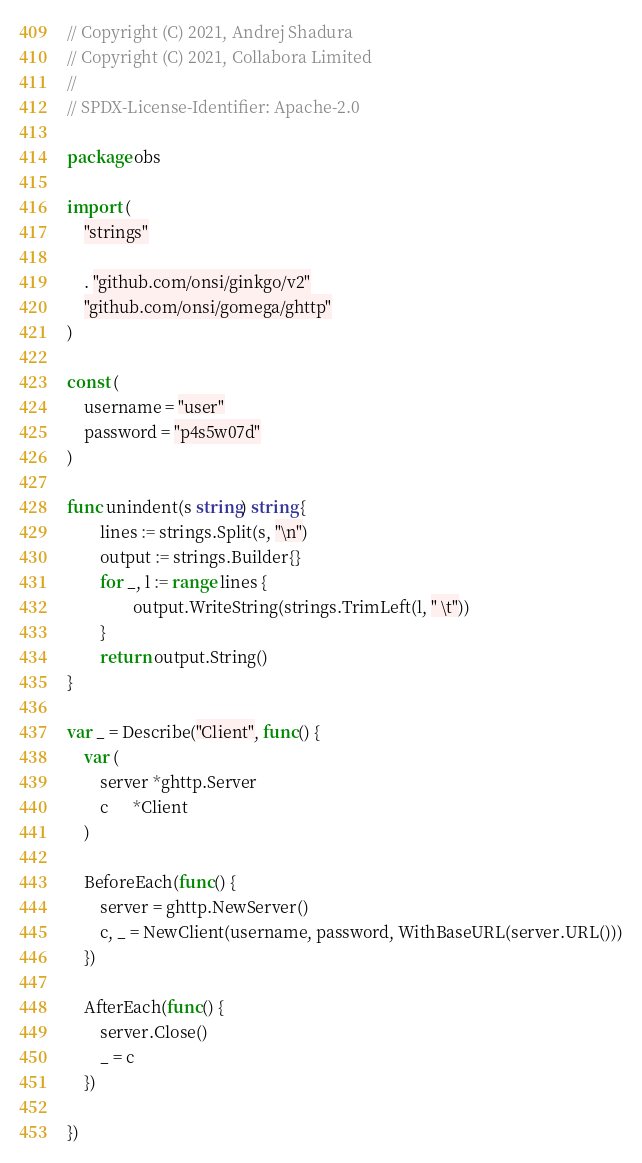<code> <loc_0><loc_0><loc_500><loc_500><_Go_>// Copyright (C) 2021, Andrej Shadura
// Copyright (C) 2021, Collabora Limited
//
// SPDX-License-Identifier: Apache-2.0

package obs

import (
	"strings"

	. "github.com/onsi/ginkgo/v2"
	"github.com/onsi/gomega/ghttp"
)

const (
	username = "user"
	password = "p4s5w07d"
)

func unindent(s string) string {
        lines := strings.Split(s, "\n")
        output := strings.Builder{}
        for _, l := range lines {
                output.WriteString(strings.TrimLeft(l, " \t"))
        }
        return output.String()
}

var _ = Describe("Client", func() {
	var (
		server *ghttp.Server
		c      *Client
	)

	BeforeEach(func() {
		server = ghttp.NewServer()
		c, _ = NewClient(username, password, WithBaseURL(server.URL()))
	})

	AfterEach(func() {
		server.Close()
		_ = c
	})

})
</code> 